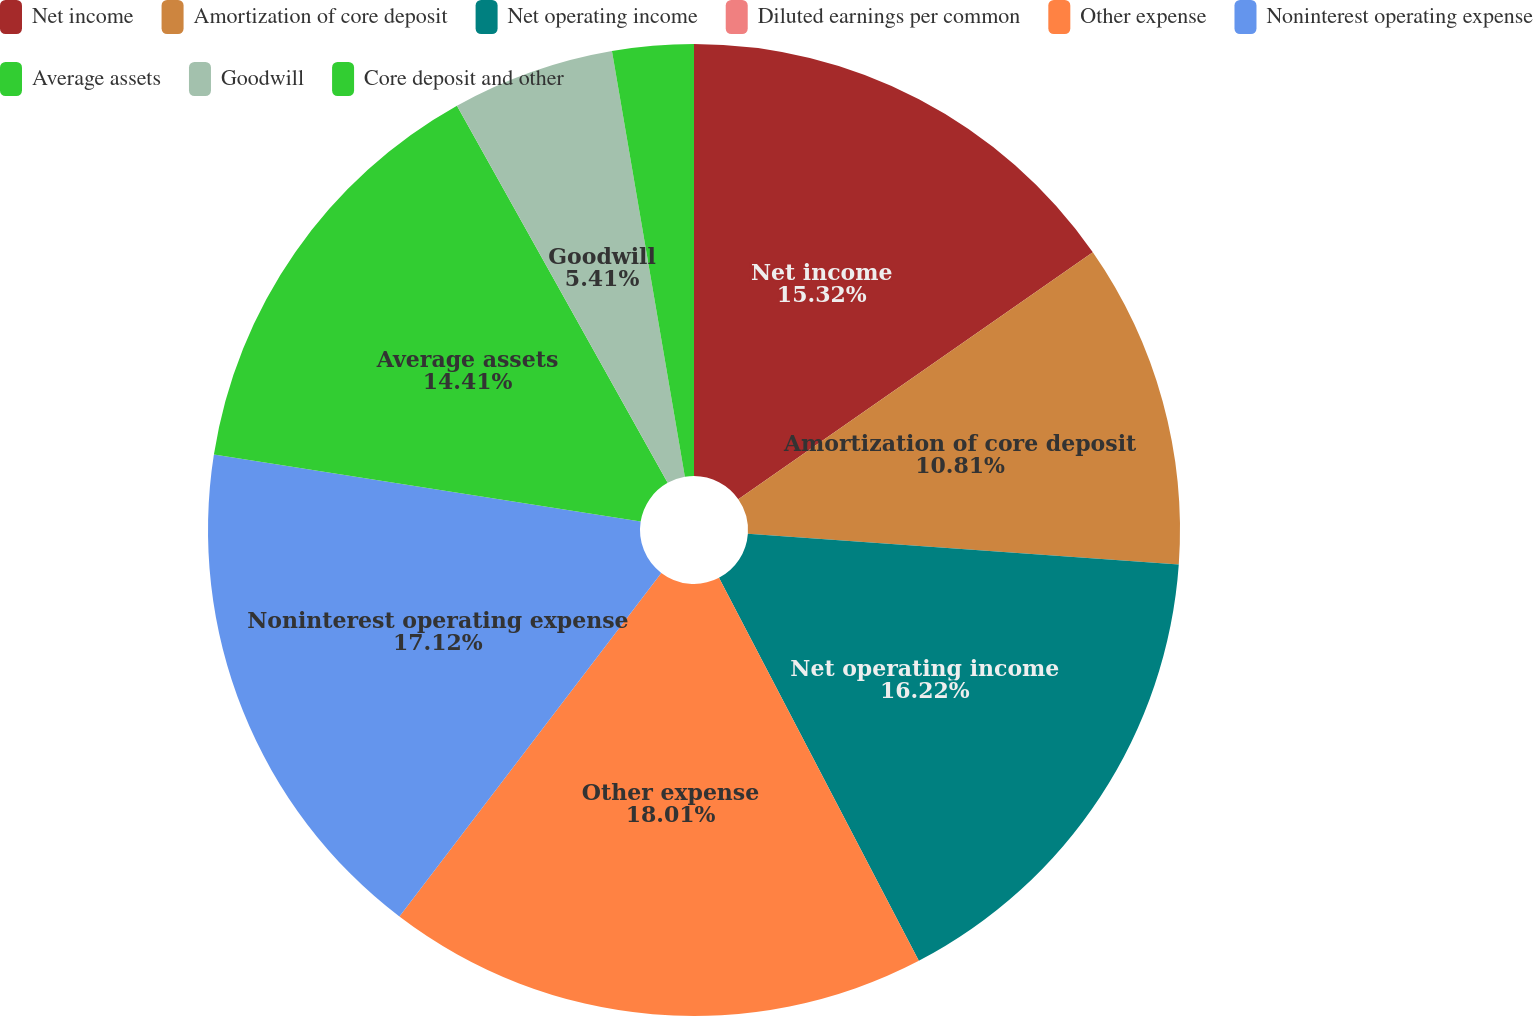Convert chart. <chart><loc_0><loc_0><loc_500><loc_500><pie_chart><fcel>Net income<fcel>Amortization of core deposit<fcel>Net operating income<fcel>Diluted earnings per common<fcel>Other expense<fcel>Noninterest operating expense<fcel>Average assets<fcel>Goodwill<fcel>Core deposit and other<nl><fcel>15.32%<fcel>10.81%<fcel>16.22%<fcel>0.0%<fcel>18.02%<fcel>17.12%<fcel>14.41%<fcel>5.41%<fcel>2.7%<nl></chart> 